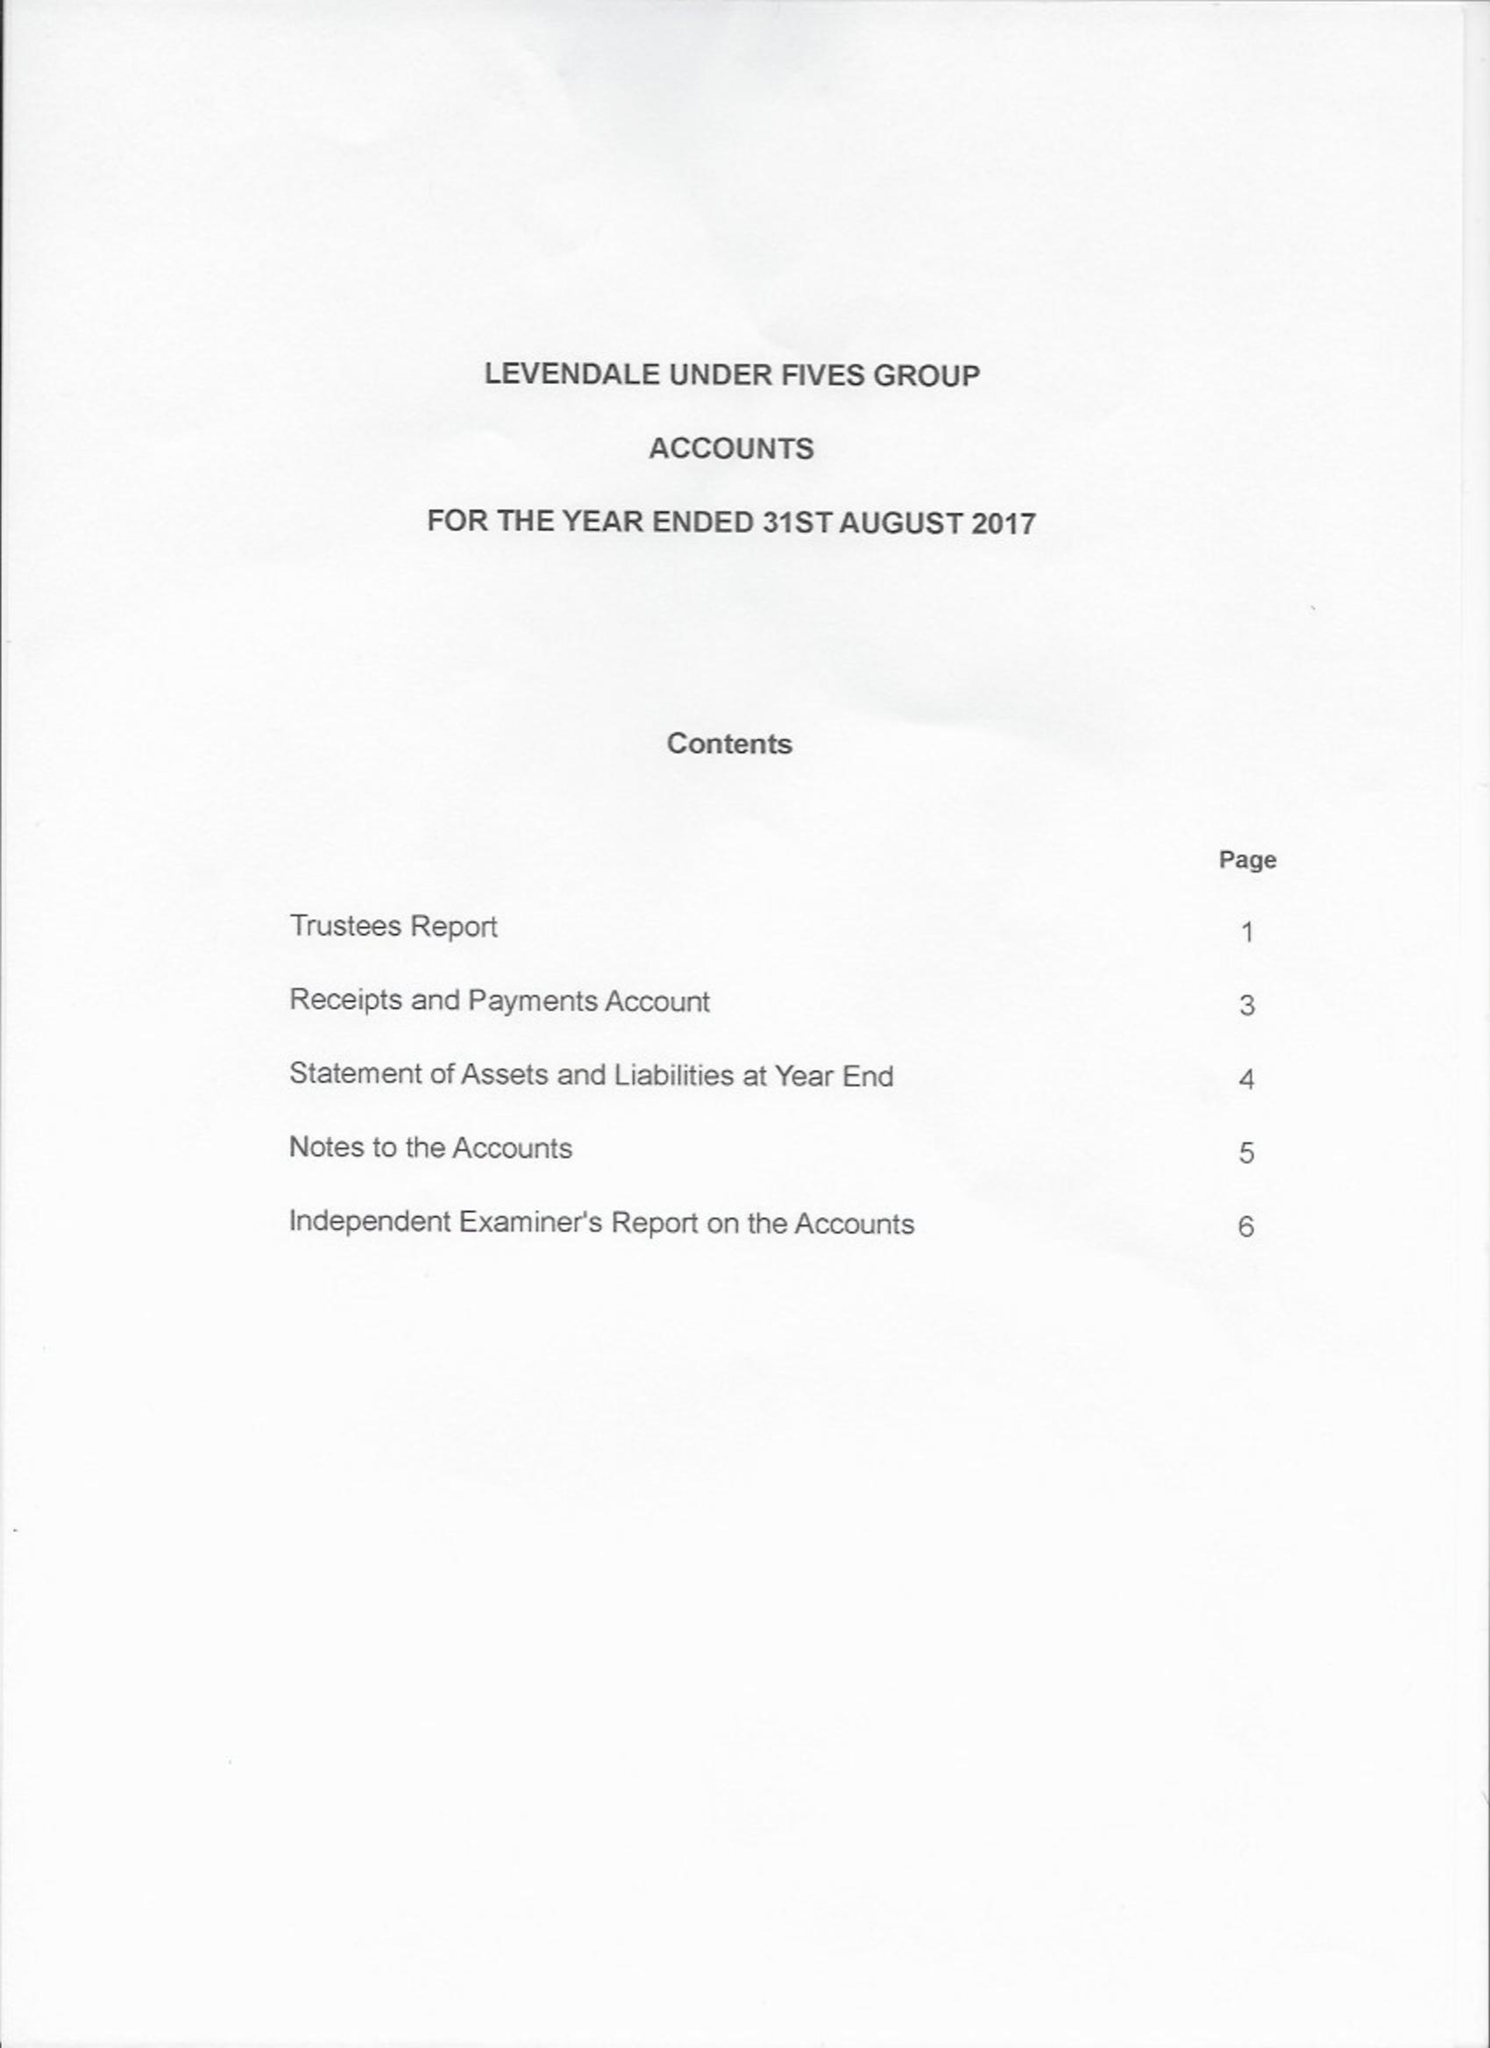What is the value for the address__post_town?
Answer the question using a single word or phrase. YARM 